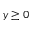<formula> <loc_0><loc_0><loc_500><loc_500>y \geq 0</formula> 